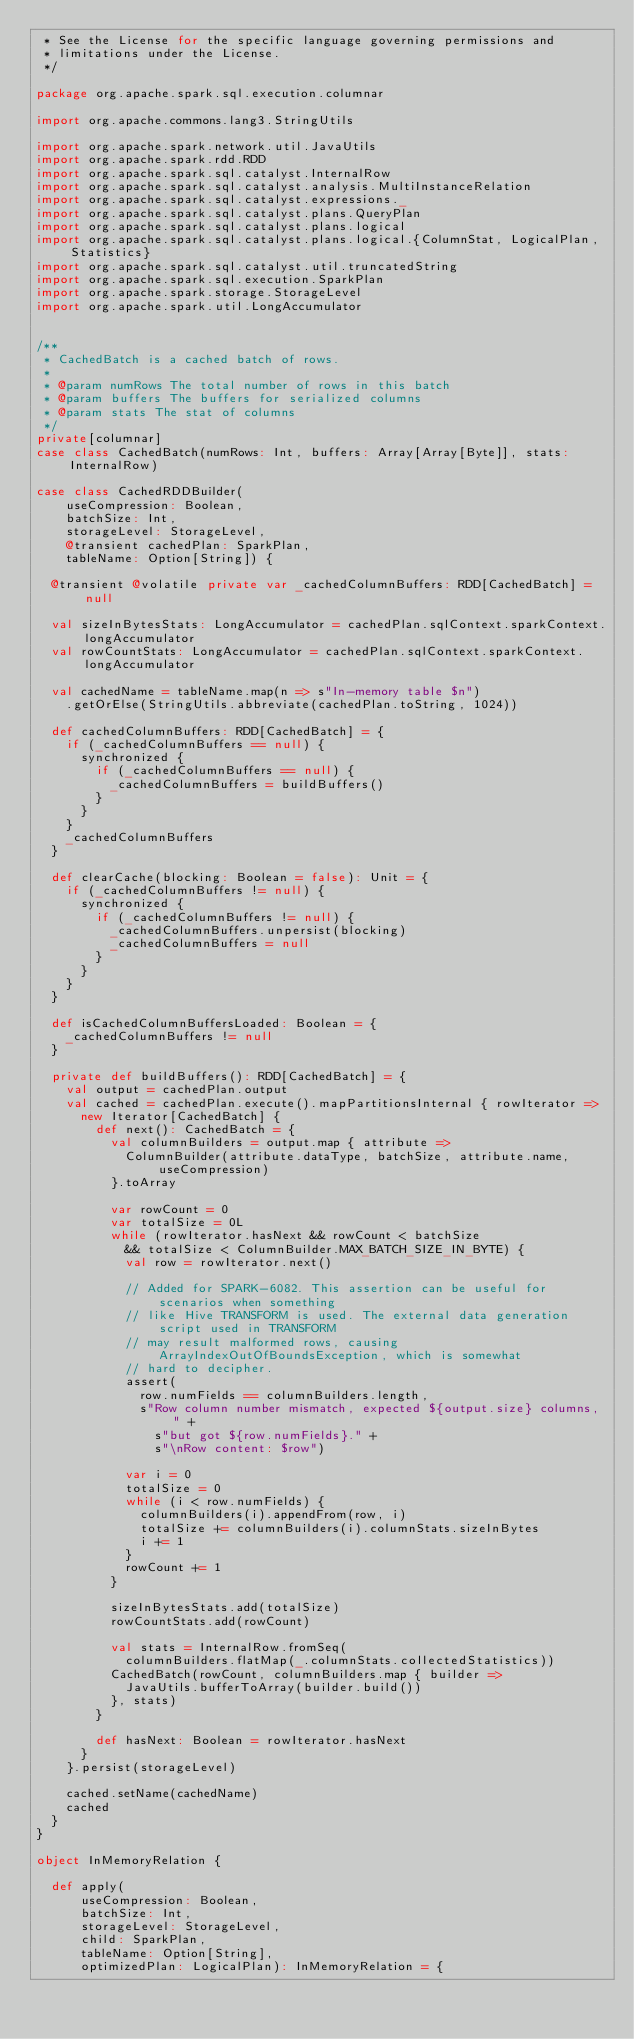<code> <loc_0><loc_0><loc_500><loc_500><_Scala_> * See the License for the specific language governing permissions and
 * limitations under the License.
 */

package org.apache.spark.sql.execution.columnar

import org.apache.commons.lang3.StringUtils

import org.apache.spark.network.util.JavaUtils
import org.apache.spark.rdd.RDD
import org.apache.spark.sql.catalyst.InternalRow
import org.apache.spark.sql.catalyst.analysis.MultiInstanceRelation
import org.apache.spark.sql.catalyst.expressions._
import org.apache.spark.sql.catalyst.plans.QueryPlan
import org.apache.spark.sql.catalyst.plans.logical
import org.apache.spark.sql.catalyst.plans.logical.{ColumnStat, LogicalPlan, Statistics}
import org.apache.spark.sql.catalyst.util.truncatedString
import org.apache.spark.sql.execution.SparkPlan
import org.apache.spark.storage.StorageLevel
import org.apache.spark.util.LongAccumulator


/**
 * CachedBatch is a cached batch of rows.
 *
 * @param numRows The total number of rows in this batch
 * @param buffers The buffers for serialized columns
 * @param stats The stat of columns
 */
private[columnar]
case class CachedBatch(numRows: Int, buffers: Array[Array[Byte]], stats: InternalRow)

case class CachedRDDBuilder(
    useCompression: Boolean,
    batchSize: Int,
    storageLevel: StorageLevel,
    @transient cachedPlan: SparkPlan,
    tableName: Option[String]) {

  @transient @volatile private var _cachedColumnBuffers: RDD[CachedBatch] = null

  val sizeInBytesStats: LongAccumulator = cachedPlan.sqlContext.sparkContext.longAccumulator
  val rowCountStats: LongAccumulator = cachedPlan.sqlContext.sparkContext.longAccumulator

  val cachedName = tableName.map(n => s"In-memory table $n")
    .getOrElse(StringUtils.abbreviate(cachedPlan.toString, 1024))

  def cachedColumnBuffers: RDD[CachedBatch] = {
    if (_cachedColumnBuffers == null) {
      synchronized {
        if (_cachedColumnBuffers == null) {
          _cachedColumnBuffers = buildBuffers()
        }
      }
    }
    _cachedColumnBuffers
  }

  def clearCache(blocking: Boolean = false): Unit = {
    if (_cachedColumnBuffers != null) {
      synchronized {
        if (_cachedColumnBuffers != null) {
          _cachedColumnBuffers.unpersist(blocking)
          _cachedColumnBuffers = null
        }
      }
    }
  }

  def isCachedColumnBuffersLoaded: Boolean = {
    _cachedColumnBuffers != null
  }

  private def buildBuffers(): RDD[CachedBatch] = {
    val output = cachedPlan.output
    val cached = cachedPlan.execute().mapPartitionsInternal { rowIterator =>
      new Iterator[CachedBatch] {
        def next(): CachedBatch = {
          val columnBuilders = output.map { attribute =>
            ColumnBuilder(attribute.dataType, batchSize, attribute.name, useCompression)
          }.toArray

          var rowCount = 0
          var totalSize = 0L
          while (rowIterator.hasNext && rowCount < batchSize
            && totalSize < ColumnBuilder.MAX_BATCH_SIZE_IN_BYTE) {
            val row = rowIterator.next()

            // Added for SPARK-6082. This assertion can be useful for scenarios when something
            // like Hive TRANSFORM is used. The external data generation script used in TRANSFORM
            // may result malformed rows, causing ArrayIndexOutOfBoundsException, which is somewhat
            // hard to decipher.
            assert(
              row.numFields == columnBuilders.length,
              s"Row column number mismatch, expected ${output.size} columns, " +
                s"but got ${row.numFields}." +
                s"\nRow content: $row")

            var i = 0
            totalSize = 0
            while (i < row.numFields) {
              columnBuilders(i).appendFrom(row, i)
              totalSize += columnBuilders(i).columnStats.sizeInBytes
              i += 1
            }
            rowCount += 1
          }

          sizeInBytesStats.add(totalSize)
          rowCountStats.add(rowCount)

          val stats = InternalRow.fromSeq(
            columnBuilders.flatMap(_.columnStats.collectedStatistics))
          CachedBatch(rowCount, columnBuilders.map { builder =>
            JavaUtils.bufferToArray(builder.build())
          }, stats)
        }

        def hasNext: Boolean = rowIterator.hasNext
      }
    }.persist(storageLevel)

    cached.setName(cachedName)
    cached
  }
}

object InMemoryRelation {

  def apply(
      useCompression: Boolean,
      batchSize: Int,
      storageLevel: StorageLevel,
      child: SparkPlan,
      tableName: Option[String],
      optimizedPlan: LogicalPlan): InMemoryRelation = {</code> 